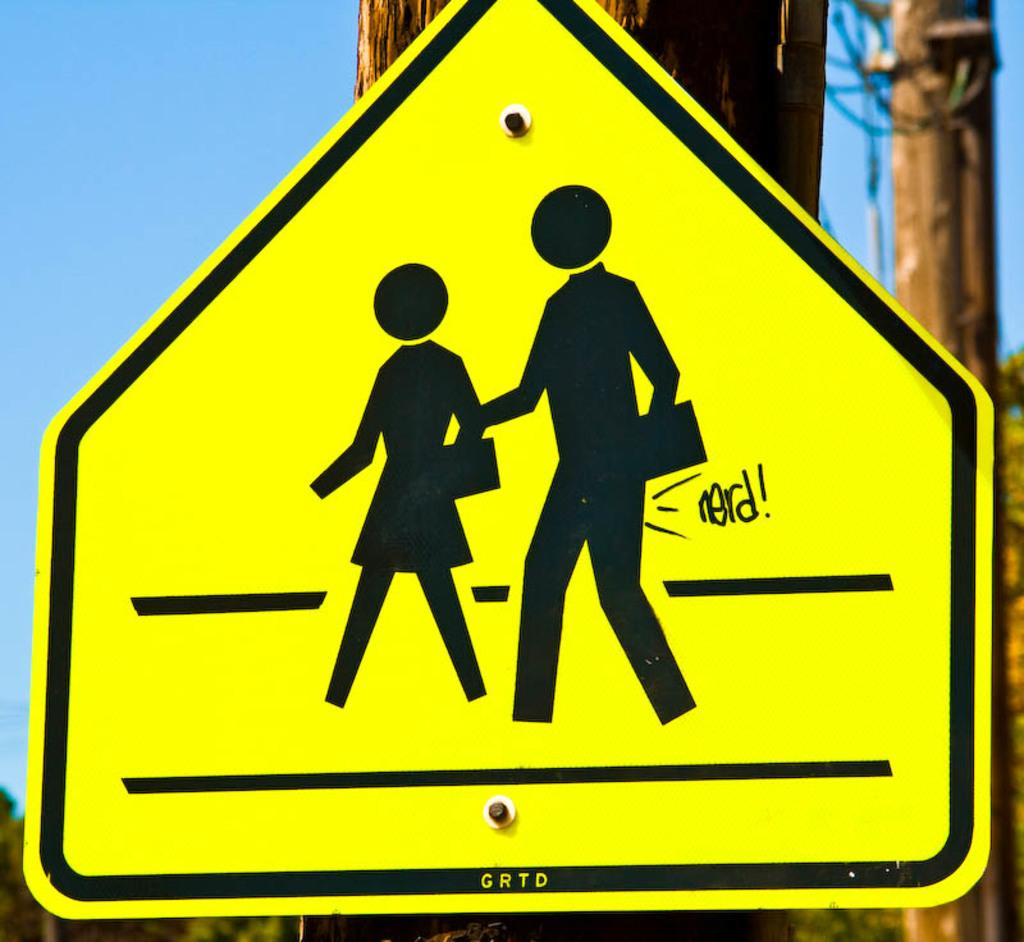<image>
Present a compact description of the photo's key features. A close up picture of a crosswalk sign that has "nerd!" on it 